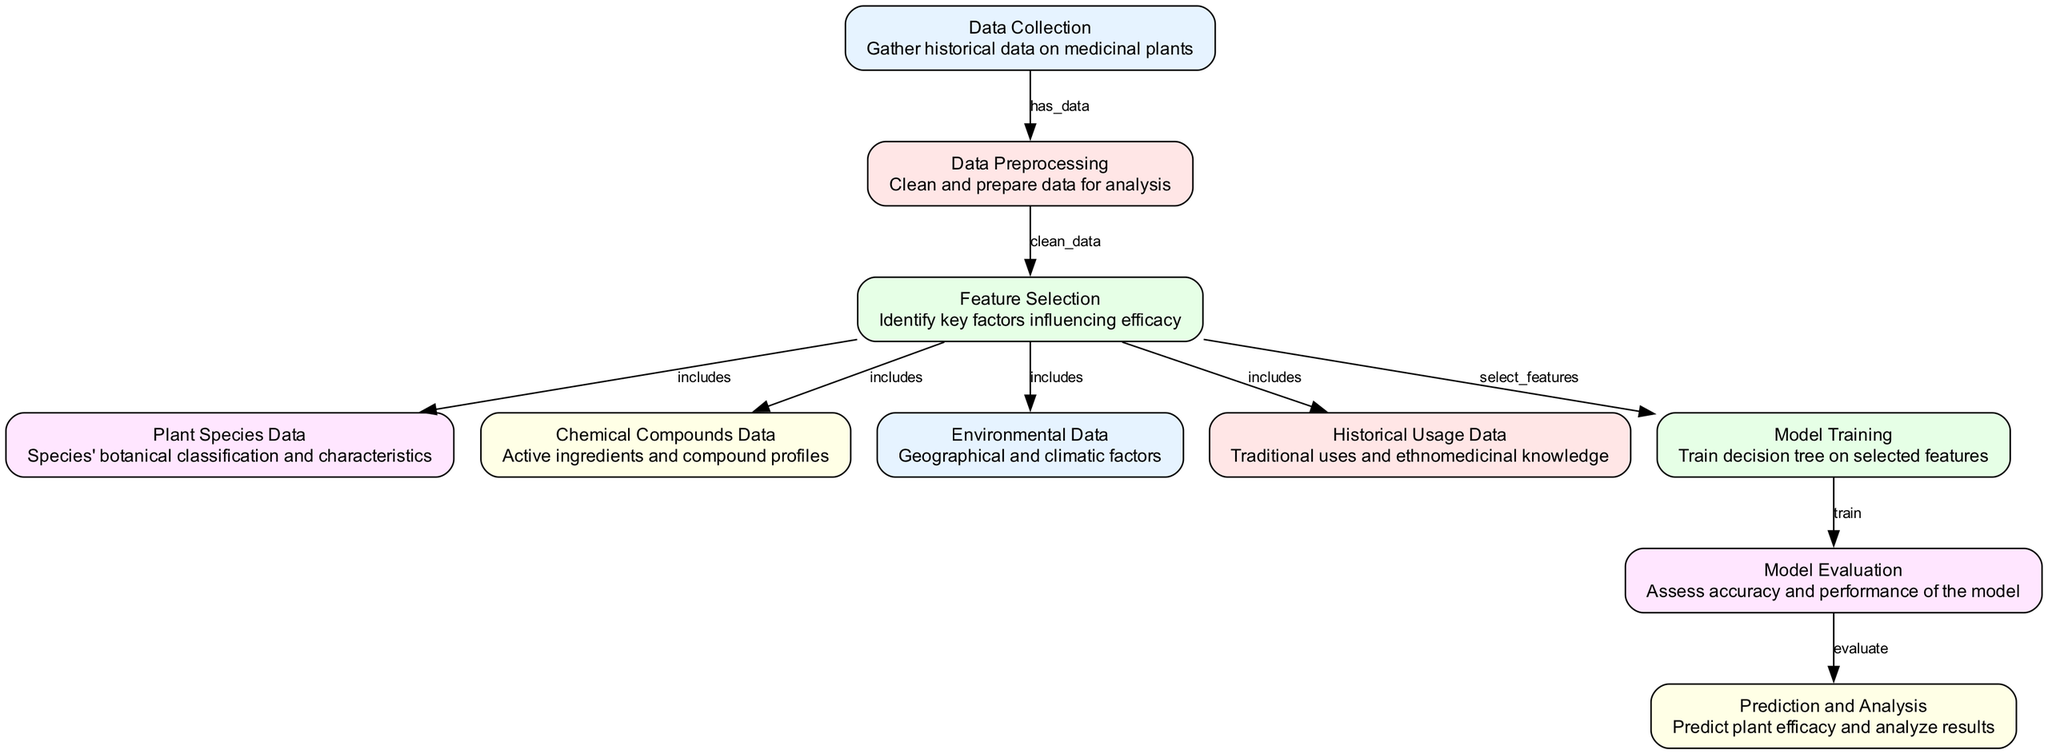What is the first step in the diagram? The diagram indicates that the first step is "Data Collection," where historical data on medicinal plants is gathered. This can be identified as it is the first node listed in the diagram flow.
Answer: Data Collection How many nodes are in the diagram? By counting the individual nodes listed in the provided structure, there are ten nodes that are part of the process flow in the diagram.
Answer: 10 What relationship exists between "Data Preprocessing" and "Feature Selection"? The relationship is labeled "clean_data," showing that "Data Preprocessing" follows "Data Collection" in the flow and provides cleaned data to the next step, which is "Feature Selection."
Answer: clean_data Which data type influences "Model Training"? The diagram indicates that "Model Training" is influenced by the "Feature Selection," which determines the input data for training the model. This is indicated by the flow direction from "Feature Selection" to "Model Training."
Answer: Feature Selection What are the factors included in "Feature Selection"? The feature selection includes "Plant Species Data," "Chemical Compounds Data," "Environmental Data," and "Historical Usage Data" as indicated by the arrows connecting them to the "Feature Selection" node.
Answer: Plant Species Data, Chemical Compounds Data, Environmental Data, Historical Usage Data What is the output of the "Model Evaluation" step? The output is described as "assess accuracy and performance of the model," which indicates that the main goal of this step is to evaluate how well the model predicts plant efficacy. This is stated in the description of the "Model Evaluation" node.
Answer: assess accuracy and performance of the model Which two nodes directly connect to "Prediction and Analysis"? The node directly connecting to "Prediction and Analysis" is "Model Evaluation," which evaluates the performance of the trained model before predicting and analyzing results.
Answer: Model Evaluation What is the last node in this process? The "Prediction and Analysis" is the last node in the process as it follows the flow of the diagram after "Model Evaluation," indicating it is the final step in the predictive analysis workflow.
Answer: Prediction and Analysis Which data type follows "Data Collection"? After "Data Collection," the next step is "Data Preprocessing," which follows in the workflow as indicated by the arrow leading from "Data Collection" to "Data Preprocessing."
Answer: Data Preprocessing What is the purpose of the "Model Training" node? The "Model Training" node's purpose is to train the decision tree model on selected features, as indicated in its description. This means it uses the features identified in the previous step to develop the model.
Answer: train decision tree on selected features 